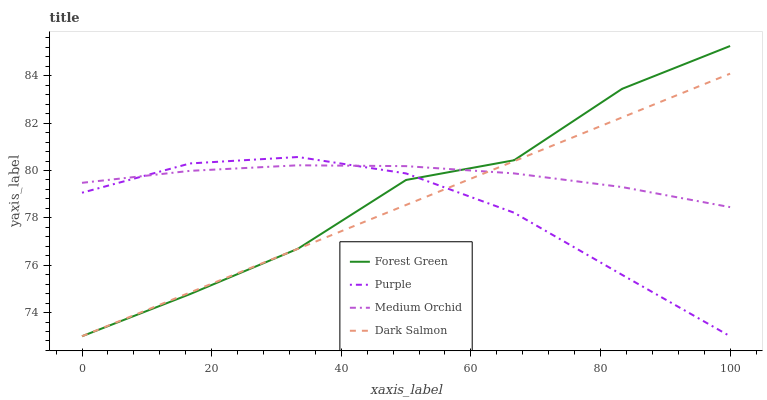Does Forest Green have the minimum area under the curve?
Answer yes or no. No. Does Forest Green have the maximum area under the curve?
Answer yes or no. No. Is Medium Orchid the smoothest?
Answer yes or no. No. Is Medium Orchid the roughest?
Answer yes or no. No. Does Medium Orchid have the lowest value?
Answer yes or no. No. Does Medium Orchid have the highest value?
Answer yes or no. No. 